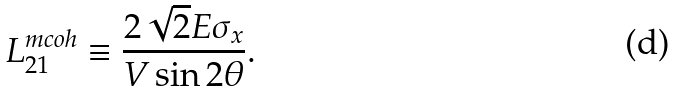<formula> <loc_0><loc_0><loc_500><loc_500>L _ { 2 1 } ^ { m c o h } \equiv \frac { 2 \sqrt { 2 } E \sigma _ { x } } { V \sin { 2 \theta } } .</formula> 